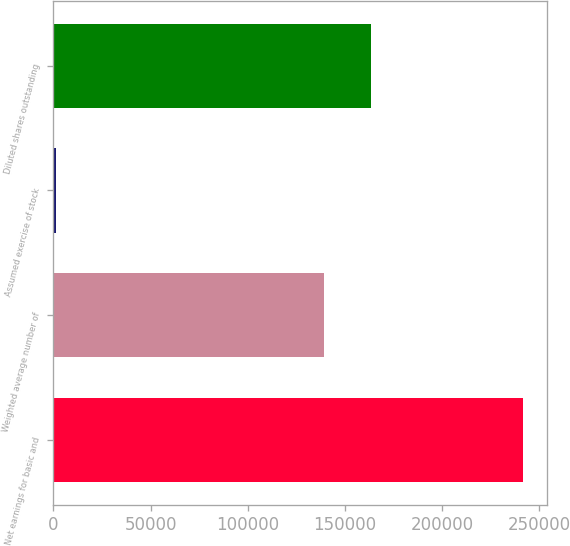Convert chart. <chart><loc_0><loc_0><loc_500><loc_500><bar_chart><fcel>Net earnings for basic and<fcel>Weighted average number of<fcel>Assumed exercise of stock<fcel>Diluted shares outstanding<nl><fcel>241686<fcel>139353<fcel>1421<fcel>163380<nl></chart> 